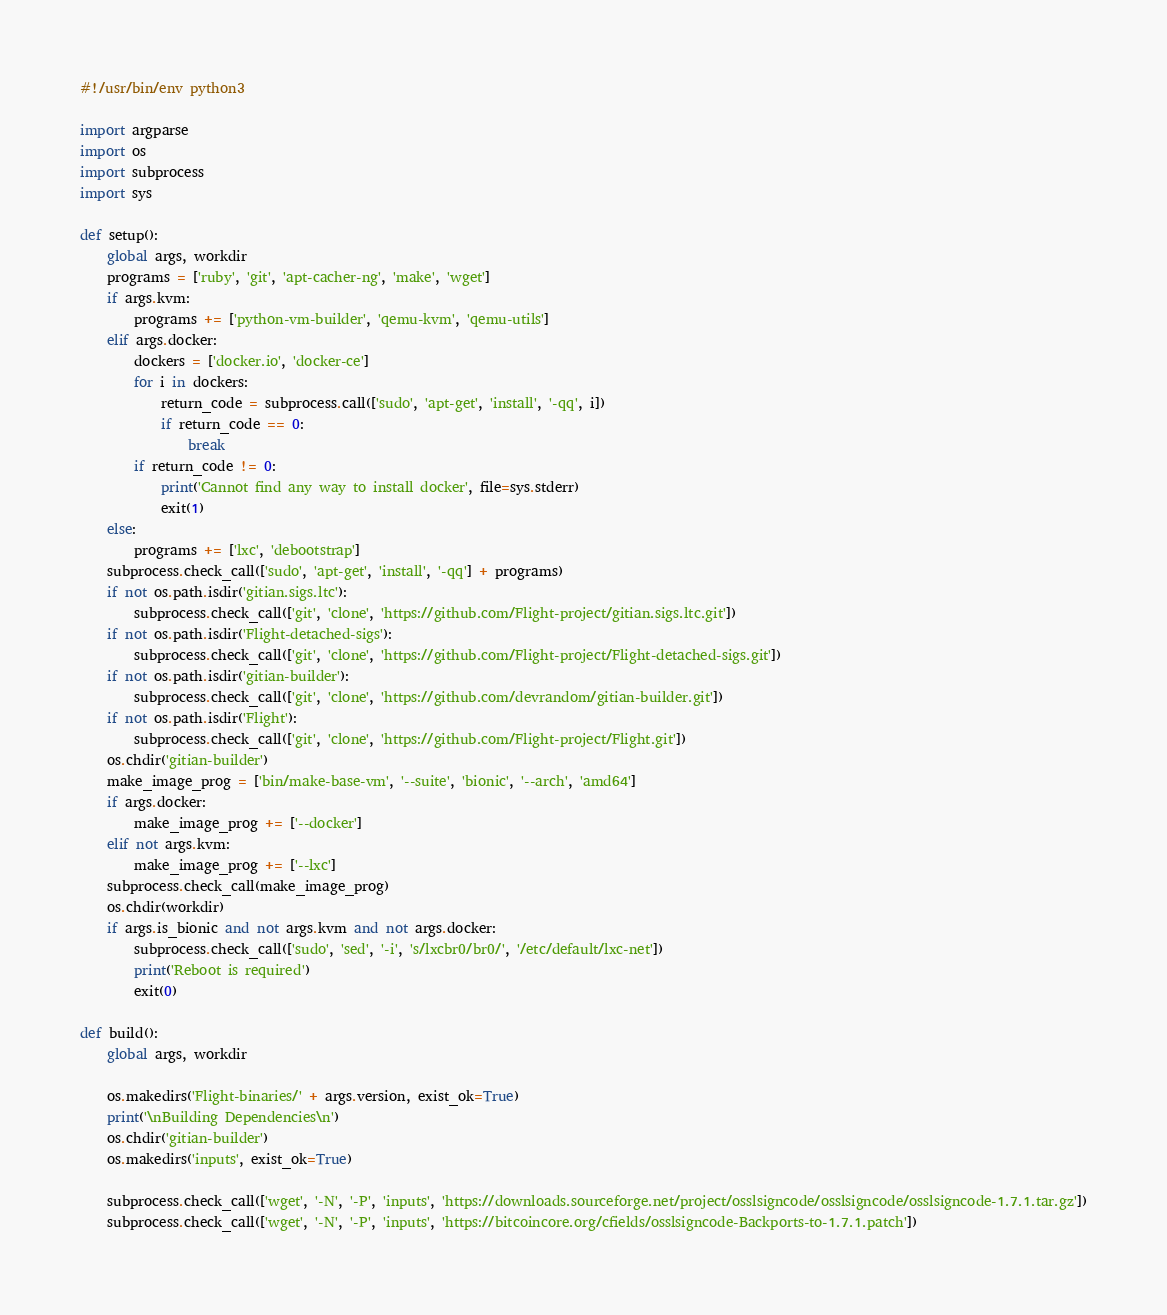Convert code to text. <code><loc_0><loc_0><loc_500><loc_500><_Python_>#!/usr/bin/env python3

import argparse
import os
import subprocess
import sys

def setup():
    global args, workdir
    programs = ['ruby', 'git', 'apt-cacher-ng', 'make', 'wget']
    if args.kvm:
        programs += ['python-vm-builder', 'qemu-kvm', 'qemu-utils']
    elif args.docker:
        dockers = ['docker.io', 'docker-ce']
        for i in dockers:
            return_code = subprocess.call(['sudo', 'apt-get', 'install', '-qq', i])
            if return_code == 0:
                break
        if return_code != 0:
            print('Cannot find any way to install docker', file=sys.stderr)
            exit(1)
    else:
        programs += ['lxc', 'debootstrap']
    subprocess.check_call(['sudo', 'apt-get', 'install', '-qq'] + programs)
    if not os.path.isdir('gitian.sigs.ltc'):
        subprocess.check_call(['git', 'clone', 'https://github.com/Flight-project/gitian.sigs.ltc.git'])
    if not os.path.isdir('Flight-detached-sigs'):
        subprocess.check_call(['git', 'clone', 'https://github.com/Flight-project/Flight-detached-sigs.git'])
    if not os.path.isdir('gitian-builder'):
        subprocess.check_call(['git', 'clone', 'https://github.com/devrandom/gitian-builder.git'])
    if not os.path.isdir('Flight'):
        subprocess.check_call(['git', 'clone', 'https://github.com/Flight-project/Flight.git'])
    os.chdir('gitian-builder')
    make_image_prog = ['bin/make-base-vm', '--suite', 'bionic', '--arch', 'amd64']
    if args.docker:
        make_image_prog += ['--docker']
    elif not args.kvm:
        make_image_prog += ['--lxc']
    subprocess.check_call(make_image_prog)
    os.chdir(workdir)
    if args.is_bionic and not args.kvm and not args.docker:
        subprocess.check_call(['sudo', 'sed', '-i', 's/lxcbr0/br0/', '/etc/default/lxc-net'])
        print('Reboot is required')
        exit(0)

def build():
    global args, workdir

    os.makedirs('Flight-binaries/' + args.version, exist_ok=True)
    print('\nBuilding Dependencies\n')
    os.chdir('gitian-builder')
    os.makedirs('inputs', exist_ok=True)

    subprocess.check_call(['wget', '-N', '-P', 'inputs', 'https://downloads.sourceforge.net/project/osslsigncode/osslsigncode/osslsigncode-1.7.1.tar.gz'])
    subprocess.check_call(['wget', '-N', '-P', 'inputs', 'https://bitcoincore.org/cfields/osslsigncode-Backports-to-1.7.1.patch'])</code> 